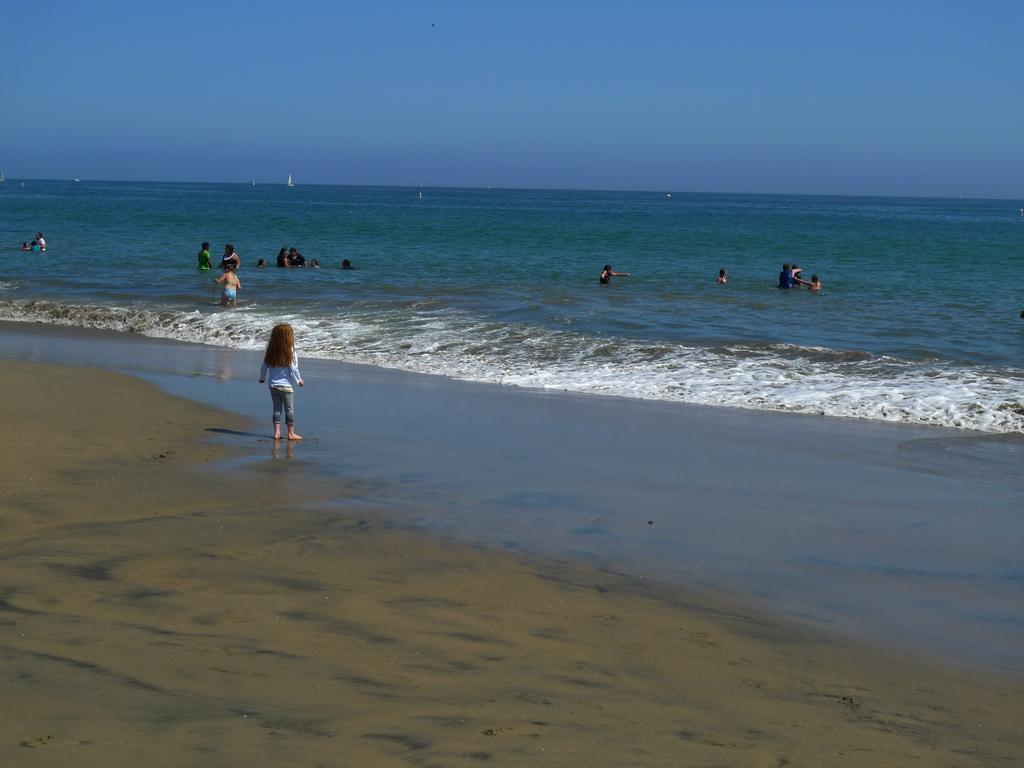Can you describe this image briefly? In this picture there are group of people in the water. In the foreground there is a girl standing. At the back there are boats on the water. At the top there is sky. At the bottom there is water and sand. 